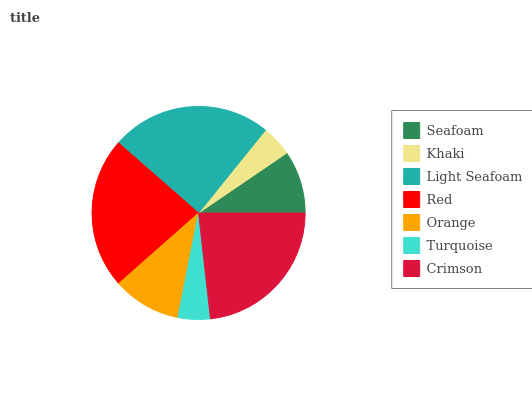Is Khaki the minimum?
Answer yes or no. Yes. Is Light Seafoam the maximum?
Answer yes or no. Yes. Is Light Seafoam the minimum?
Answer yes or no. No. Is Khaki the maximum?
Answer yes or no. No. Is Light Seafoam greater than Khaki?
Answer yes or no. Yes. Is Khaki less than Light Seafoam?
Answer yes or no. Yes. Is Khaki greater than Light Seafoam?
Answer yes or no. No. Is Light Seafoam less than Khaki?
Answer yes or no. No. Is Orange the high median?
Answer yes or no. Yes. Is Orange the low median?
Answer yes or no. Yes. Is Turquoise the high median?
Answer yes or no. No. Is Turquoise the low median?
Answer yes or no. No. 